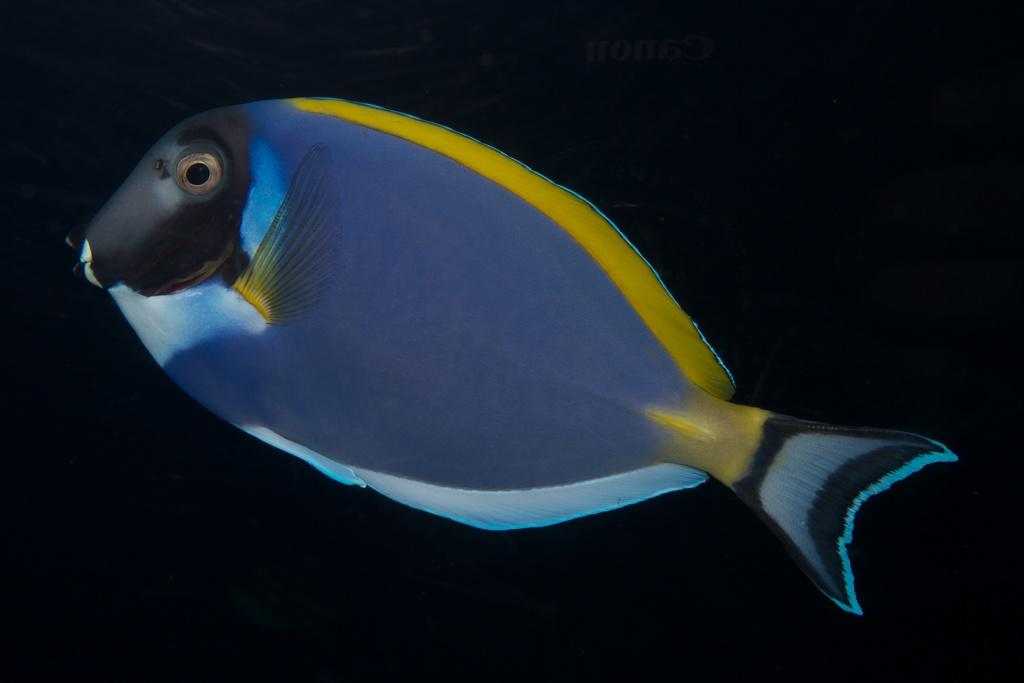What is the main subject of the picture? There is a fish in the picture. What color is the background of the picture? The background of the picture is black. Is there any text in the picture? Yes, there is text at the top of the picture. What colors are used to depict the fish? The fish is in blue and yellow colors. Can you tell me how many spots are on the fish in the image? There are no spots visible on the fish in the image; it is depicted in blue and yellow colors. What type of writing can be seen on the fish in the image? There is no writing present on the fish in the image; it is a fish depicted in blue and yellow colors. 